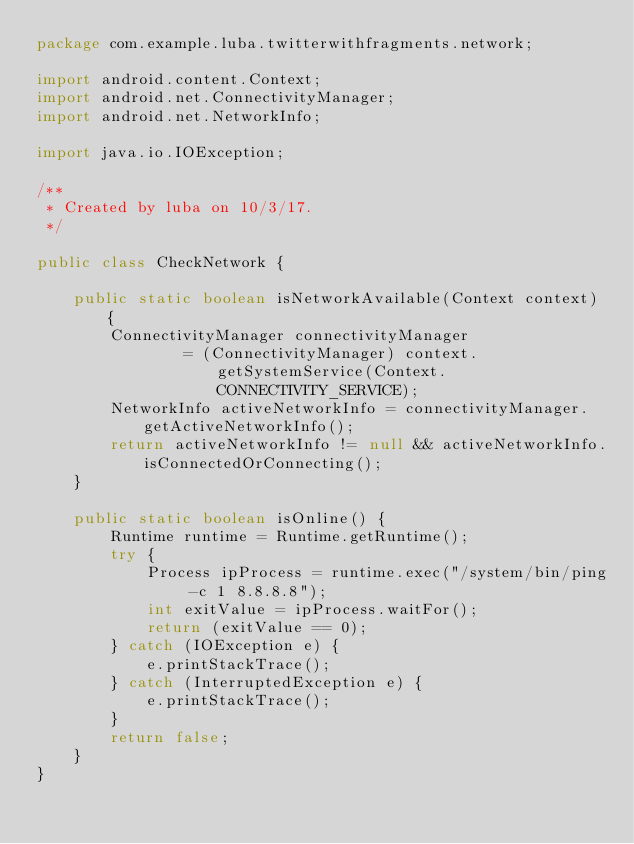Convert code to text. <code><loc_0><loc_0><loc_500><loc_500><_Java_>package com.example.luba.twitterwithfragments.network;

import android.content.Context;
import android.net.ConnectivityManager;
import android.net.NetworkInfo;

import java.io.IOException;

/**
 * Created by luba on 10/3/17.
 */

public class CheckNetwork {

    public static boolean isNetworkAvailable(Context context) {
        ConnectivityManager connectivityManager
                = (ConnectivityManager) context.getSystemService(Context.CONNECTIVITY_SERVICE);
        NetworkInfo activeNetworkInfo = connectivityManager.getActiveNetworkInfo();
        return activeNetworkInfo != null && activeNetworkInfo.isConnectedOrConnecting();
    }

    public static boolean isOnline() {
        Runtime runtime = Runtime.getRuntime();
        try {
            Process ipProcess = runtime.exec("/system/bin/ping -c 1 8.8.8.8");
            int exitValue = ipProcess.waitFor();
            return (exitValue == 0);
        } catch (IOException e) {
            e.printStackTrace();
        } catch (InterruptedException e) {
            e.printStackTrace();
        }
        return false;
    }
}
</code> 